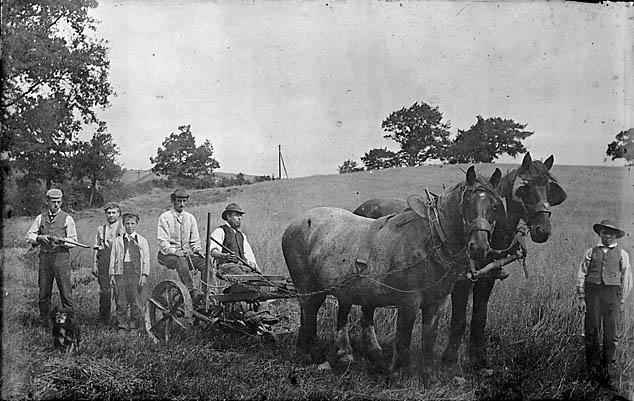How many wagon wheels are visible?
Give a very brief answer. 1. How many horses?
Give a very brief answer. 2. How many animals are there?
Give a very brief answer. 2. How many people are there?
Give a very brief answer. 5. How many horses can you see?
Give a very brief answer. 2. How many umbrellas have more than 4 colors?
Give a very brief answer. 0. 